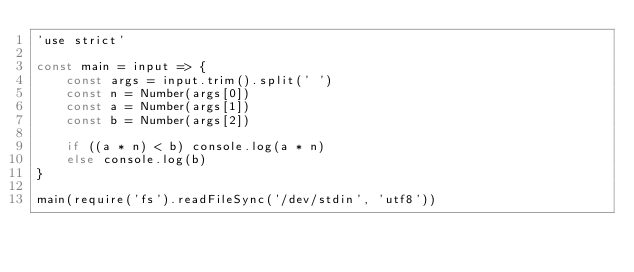Convert code to text. <code><loc_0><loc_0><loc_500><loc_500><_JavaScript_>'use strict'

const main = input => {
	const args = input.trim().split(' ')
	const n = Number(args[0])
	const a = Number(args[1])
	const b = Number(args[2])

	if ((a * n) < b) console.log(a * n)
	else console.log(b)
}

main(require('fs').readFileSync('/dev/stdin', 'utf8'))
</code> 